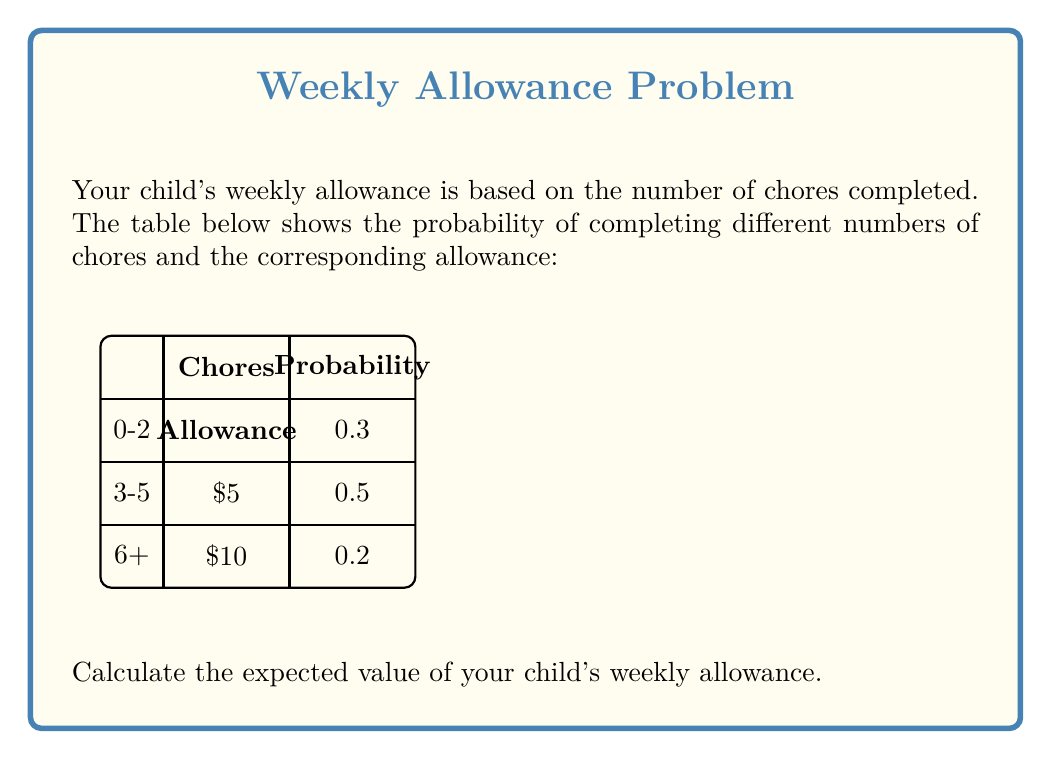Help me with this question. To calculate the expected value, we need to multiply each possible outcome by its probability and then sum these products. Let's break it down step-by-step:

1) First, let's identify the possible outcomes and their probabilities:
   - 0-2 chores: $5 allowance with probability 0.3
   - 3-5 chores: $5 allowance with probability 0.5
   - 6+ chores: $10 allowance with probability 0.2

2) Now, let's calculate the expected value using the formula:
   $$ E(X) = \sum_{i=1}^{n} x_i \cdot p(x_i) $$
   where $x_i$ is each possible outcome and $p(x_i)$ is its probability.

3) Plugging in our values:
   $$ E(X) = (5 \cdot 0.3) + (5 \cdot 0.5) + (10 \cdot 0.2) $$

4) Let's calculate each term:
   $$ E(X) = 1.5 + 2.5 + 2 $$

5) Sum up the terms:
   $$ E(X) = 6 $$

Therefore, the expected value of your child's weekly allowance is $6.
Answer: $6 